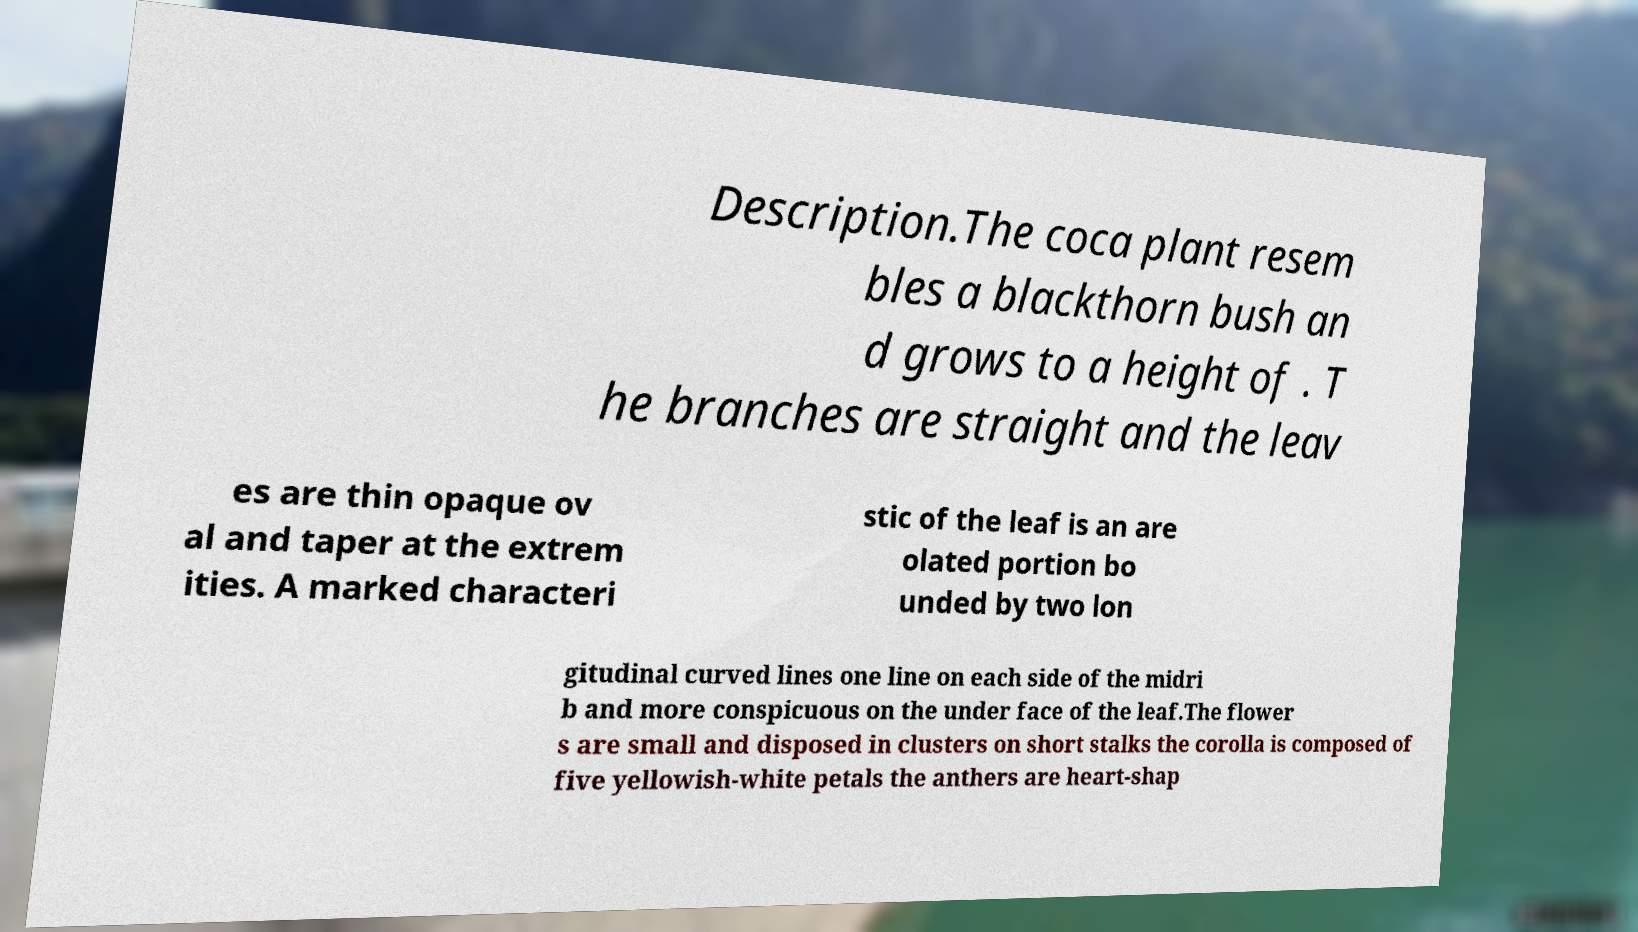I need the written content from this picture converted into text. Can you do that? Description.The coca plant resem bles a blackthorn bush an d grows to a height of . T he branches are straight and the leav es are thin opaque ov al and taper at the extrem ities. A marked characteri stic of the leaf is an are olated portion bo unded by two lon gitudinal curved lines one line on each side of the midri b and more conspicuous on the under face of the leaf.The flower s are small and disposed in clusters on short stalks the corolla is composed of five yellowish-white petals the anthers are heart-shap 